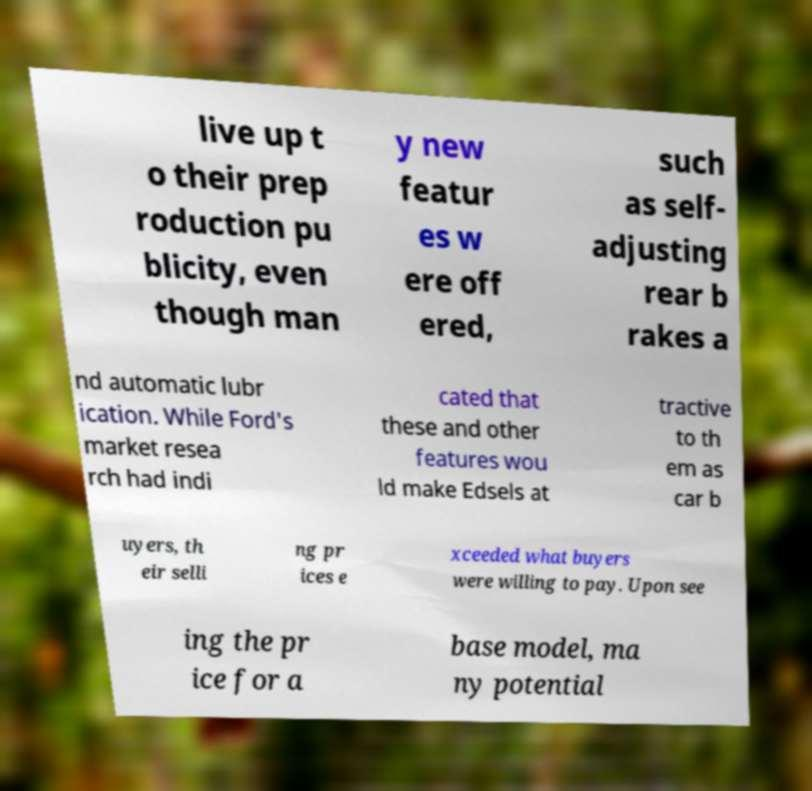Could you assist in decoding the text presented in this image and type it out clearly? live up t o their prep roduction pu blicity, even though man y new featur es w ere off ered, such as self- adjusting rear b rakes a nd automatic lubr ication. While Ford's market resea rch had indi cated that these and other features wou ld make Edsels at tractive to th em as car b uyers, th eir selli ng pr ices e xceeded what buyers were willing to pay. Upon see ing the pr ice for a base model, ma ny potential 